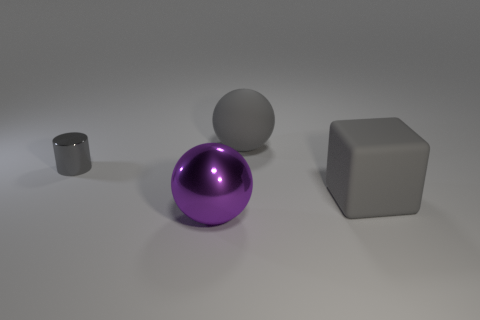There is a large ball behind the large thing that is to the right of the large ball that is behind the big metallic sphere; what is its material?
Offer a terse response. Rubber. Are there any tiny cylinders of the same color as the cube?
Your response must be concise. Yes. Are there fewer big gray rubber things behind the large gray sphere than objects?
Your answer should be very brief. Yes. There is a gray object that is in front of the cylinder; does it have the same size as the big shiny thing?
Keep it short and to the point. Yes. How many objects are both left of the large gray block and in front of the gray cylinder?
Provide a succinct answer. 1. There is a sphere that is on the left side of the big gray matte thing that is behind the gray shiny thing; what is its size?
Provide a short and direct response. Large. Is the number of big gray rubber cubes that are on the left side of the small object less than the number of large matte objects to the left of the gray block?
Offer a very short reply. Yes. Does the large rubber thing to the left of the large gray matte cube have the same color as the big thing right of the large gray rubber ball?
Provide a short and direct response. Yes. What material is the big thing that is behind the big purple metal object and in front of the gray matte sphere?
Offer a very short reply. Rubber. Are any small green matte cylinders visible?
Ensure brevity in your answer.  No. 